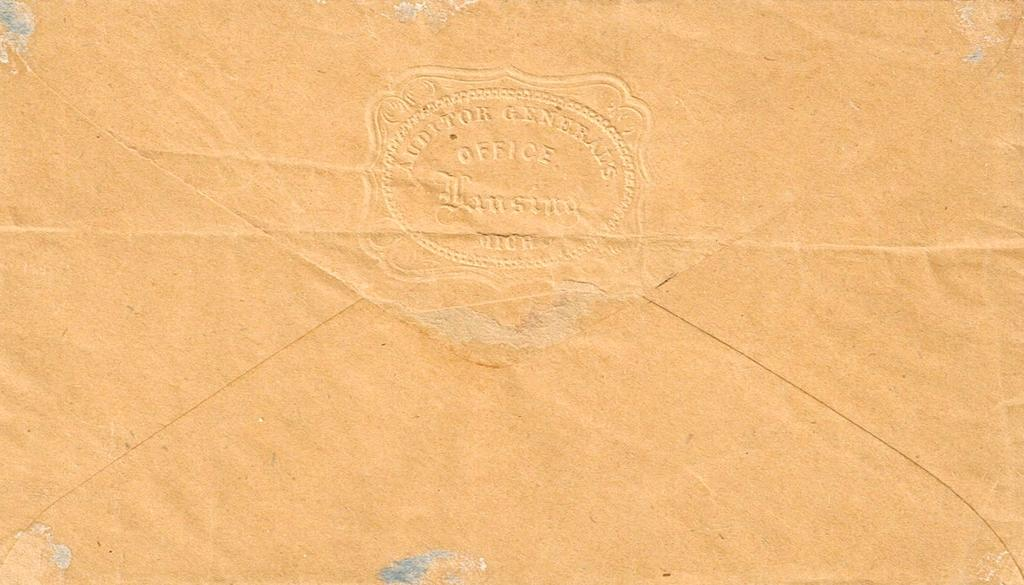<image>
Summarize the visual content of the image. A seal with the word office in the middle is stamped onto the back of an envelope. 